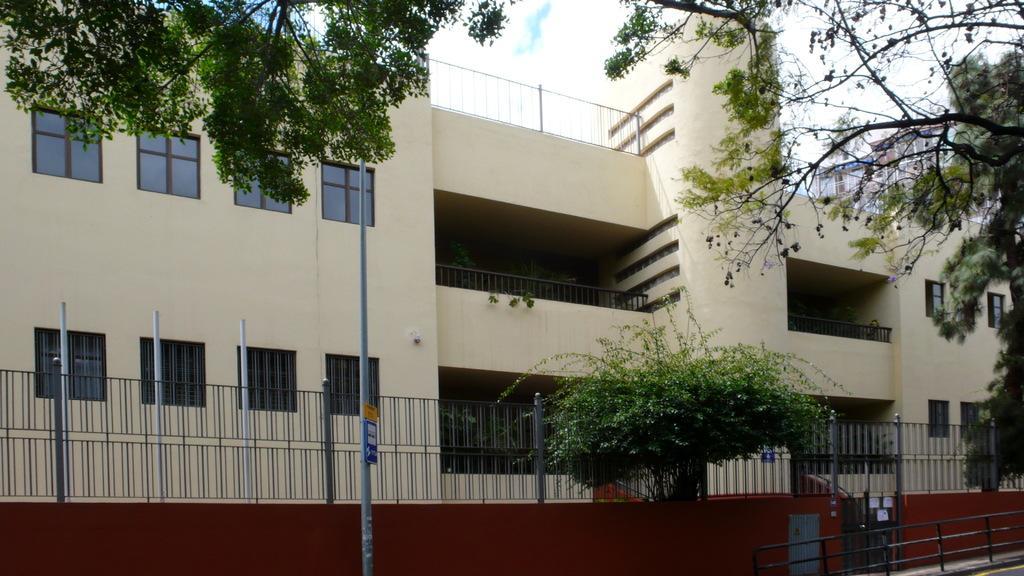Can you describe this image briefly? In this image we can see a building with windows and a fence. We can also see a board to a pole, plants, trees and the sky which looks cloudy. 